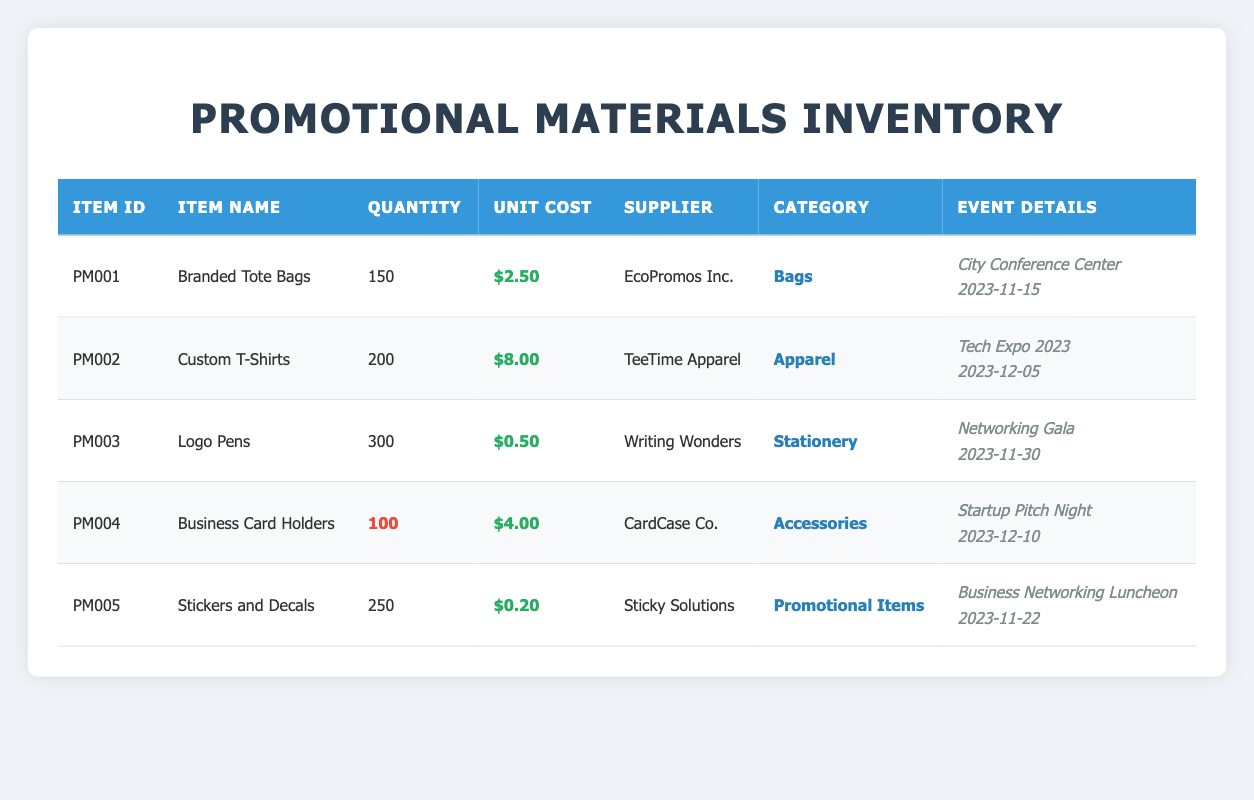What is the total quantity of Branded Tote Bags available in stock? The table shows that the quantity on hand for Branded Tote Bags is listed as 150. Therefore, this is the total quantity available in stock.
Answer: 150 Which item has the highest unit cost? By reviewing the unit cost column, Custom T-Shirts have a unit cost of $8.00, which is higher than the other items listed.
Answer: Custom T-Shirts Are there any items supplied by Sticky Solutions? The table indicates that Stickers and Decals is supplied by Sticky Solutions. Thus, there is at least one item from this supplier.
Answer: Yes What is the average unit cost of the items available? To find the average, we first calculate the total unit cost: $2.50 + $8.00 + $0.50 + $4.00 + $0.20 = $15.20. There are 5 items, so the average is $15.20 / 5 = $3.04.
Answer: 3.04 How many items are scheduled for events taking place in November 2023? The table shows three events in November (Branded Tote Bags on November 15, Logo Pens on November 30, and Stickers and Decals on November 22). Thus, there are three items associated with November events.
Answer: 3 What is the total quantity of items that fall under the category "Apparel"? Referring to the table, Custom T-Shirts is the only item in the Apparel category with a quantity on hand of 200. Thus, the total for this category is 200.
Answer: 200 Is the quantity of Business Card Holders considered low stock? The table highlights Business Card Holders with a quantity of 100, which is specifically marked as low stock. Therefore, it confirms this item is indeed low stock.
Answer: Yes What is the total cost of all Logo Pens available in stock? The quantity of Logo Pens is 300, and the unit cost is $0.50. Multiplying these provides a total cost: 300 * $0.50 = $150.
Answer: 150 Which item has the least quantity on hand, and what is that quantity? The table shows Business Card Holders have the least quantity on hand with 100, lower than any other item listed.
Answer: Business Card Holders, 100 